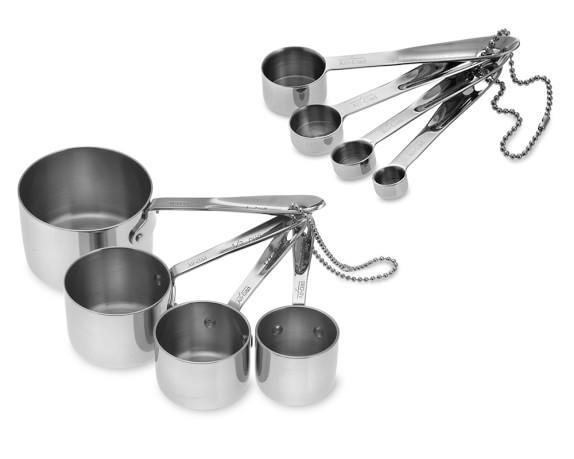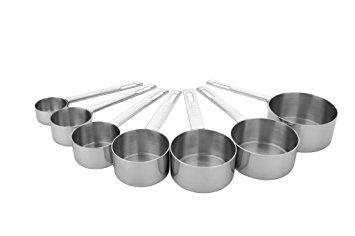The first image is the image on the left, the second image is the image on the right. Assess this claim about the two images: "An image features only a joined group of exactly four measuring cups.". Correct or not? Answer yes or no. No. 